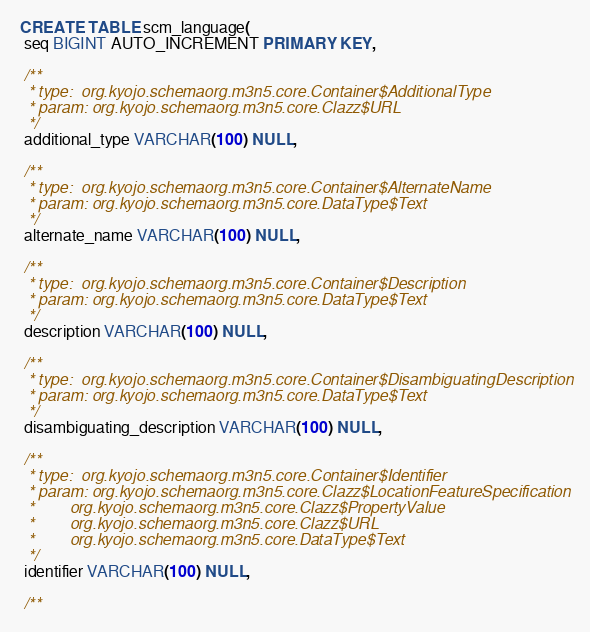Convert code to text. <code><loc_0><loc_0><loc_500><loc_500><_SQL_>CREATE TABLE scm_language(
 seq BIGINT AUTO_INCREMENT PRIMARY KEY,

 /**
  * type:  org.kyojo.schemaorg.m3n5.core.Container$AdditionalType
  * param: org.kyojo.schemaorg.m3n5.core.Clazz$URL
  */
 additional_type VARCHAR(100) NULL,

 /**
  * type:  org.kyojo.schemaorg.m3n5.core.Container$AlternateName
  * param: org.kyojo.schemaorg.m3n5.core.DataType$Text
  */
 alternate_name VARCHAR(100) NULL,

 /**
  * type:  org.kyojo.schemaorg.m3n5.core.Container$Description
  * param: org.kyojo.schemaorg.m3n5.core.DataType$Text
  */
 description VARCHAR(100) NULL,

 /**
  * type:  org.kyojo.schemaorg.m3n5.core.Container$DisambiguatingDescription
  * param: org.kyojo.schemaorg.m3n5.core.DataType$Text
  */
 disambiguating_description VARCHAR(100) NULL,

 /**
  * type:  org.kyojo.schemaorg.m3n5.core.Container$Identifier
  * param: org.kyojo.schemaorg.m3n5.core.Clazz$LocationFeatureSpecification
  *        org.kyojo.schemaorg.m3n5.core.Clazz$PropertyValue
  *        org.kyojo.schemaorg.m3n5.core.Clazz$URL
  *        org.kyojo.schemaorg.m3n5.core.DataType$Text
  */
 identifier VARCHAR(100) NULL,

 /**</code> 